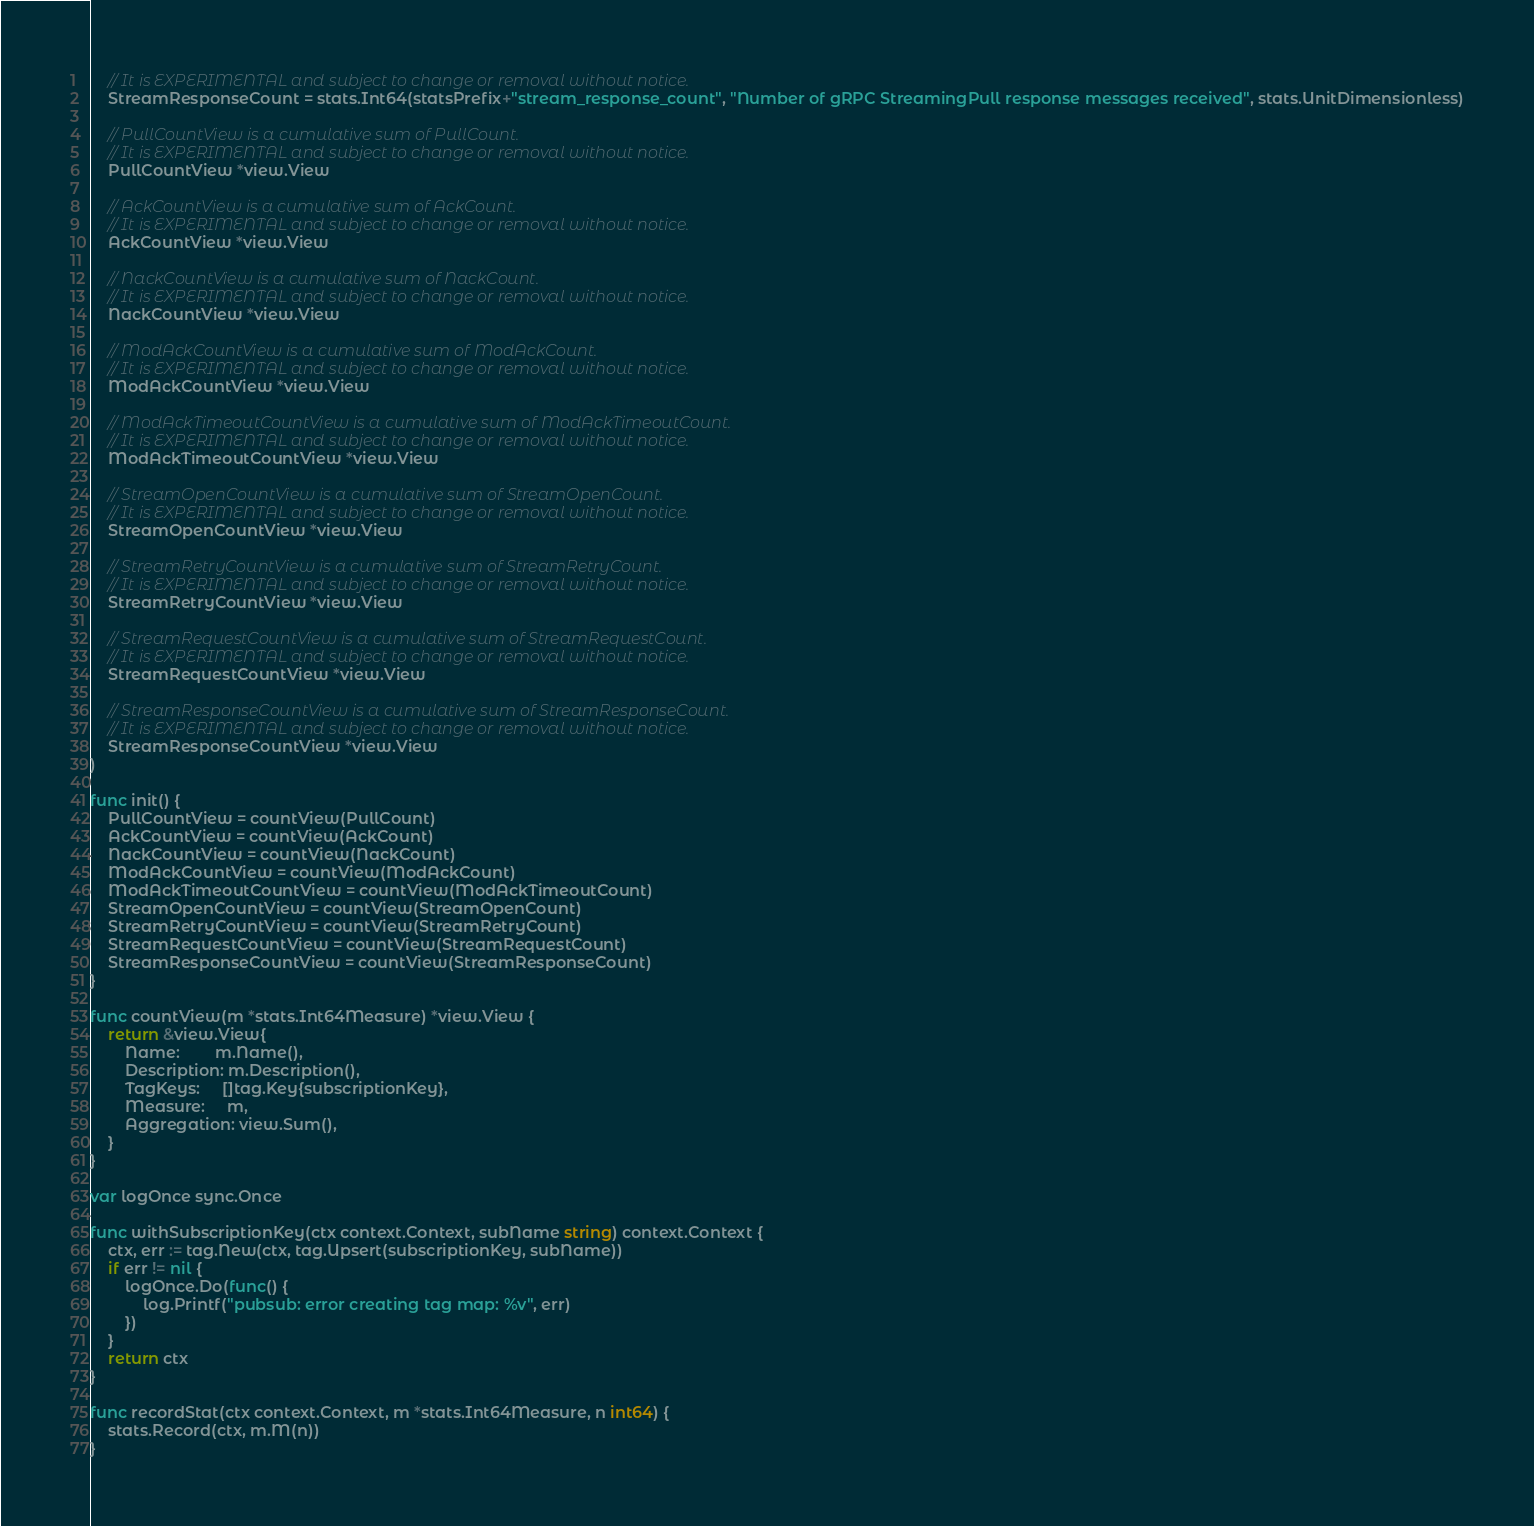Convert code to text. <code><loc_0><loc_0><loc_500><loc_500><_Go_>	// It is EXPERIMENTAL and subject to change or removal without notice.
	StreamResponseCount = stats.Int64(statsPrefix+"stream_response_count", "Number of gRPC StreamingPull response messages received", stats.UnitDimensionless)

	// PullCountView is a cumulative sum of PullCount.
	// It is EXPERIMENTAL and subject to change or removal without notice.
	PullCountView *view.View

	// AckCountView is a cumulative sum of AckCount.
	// It is EXPERIMENTAL and subject to change or removal without notice.
	AckCountView *view.View

	// NackCountView is a cumulative sum of NackCount.
	// It is EXPERIMENTAL and subject to change or removal without notice.
	NackCountView *view.View

	// ModAckCountView is a cumulative sum of ModAckCount.
	// It is EXPERIMENTAL and subject to change or removal without notice.
	ModAckCountView *view.View

	// ModAckTimeoutCountView is a cumulative sum of ModAckTimeoutCount.
	// It is EXPERIMENTAL and subject to change or removal without notice.
	ModAckTimeoutCountView *view.View

	// StreamOpenCountView is a cumulative sum of StreamOpenCount.
	// It is EXPERIMENTAL and subject to change or removal without notice.
	StreamOpenCountView *view.View

	// StreamRetryCountView is a cumulative sum of StreamRetryCount.
	// It is EXPERIMENTAL and subject to change or removal without notice.
	StreamRetryCountView *view.View

	// StreamRequestCountView is a cumulative sum of StreamRequestCount.
	// It is EXPERIMENTAL and subject to change or removal without notice.
	StreamRequestCountView *view.View

	// StreamResponseCountView is a cumulative sum of StreamResponseCount.
	// It is EXPERIMENTAL and subject to change or removal without notice.
	StreamResponseCountView *view.View
)

func init() {
	PullCountView = countView(PullCount)
	AckCountView = countView(AckCount)
	NackCountView = countView(NackCount)
	ModAckCountView = countView(ModAckCount)
	ModAckTimeoutCountView = countView(ModAckTimeoutCount)
	StreamOpenCountView = countView(StreamOpenCount)
	StreamRetryCountView = countView(StreamRetryCount)
	StreamRequestCountView = countView(StreamRequestCount)
	StreamResponseCountView = countView(StreamResponseCount)
}

func countView(m *stats.Int64Measure) *view.View {
	return &view.View{
		Name:        m.Name(),
		Description: m.Description(),
		TagKeys:     []tag.Key{subscriptionKey},
		Measure:     m,
		Aggregation: view.Sum(),
	}
}

var logOnce sync.Once

func withSubscriptionKey(ctx context.Context, subName string) context.Context {
	ctx, err := tag.New(ctx, tag.Upsert(subscriptionKey, subName))
	if err != nil {
		logOnce.Do(func() {
			log.Printf("pubsub: error creating tag map: %v", err)
		})
	}
	return ctx
}

func recordStat(ctx context.Context, m *stats.Int64Measure, n int64) {
	stats.Record(ctx, m.M(n))
}
</code> 